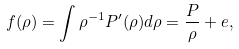Convert formula to latex. <formula><loc_0><loc_0><loc_500><loc_500>f ( \rho ) = \int \rho ^ { - 1 } P ^ { \prime } ( \rho ) d \rho = \frac { P } { \rho } + e ,</formula> 